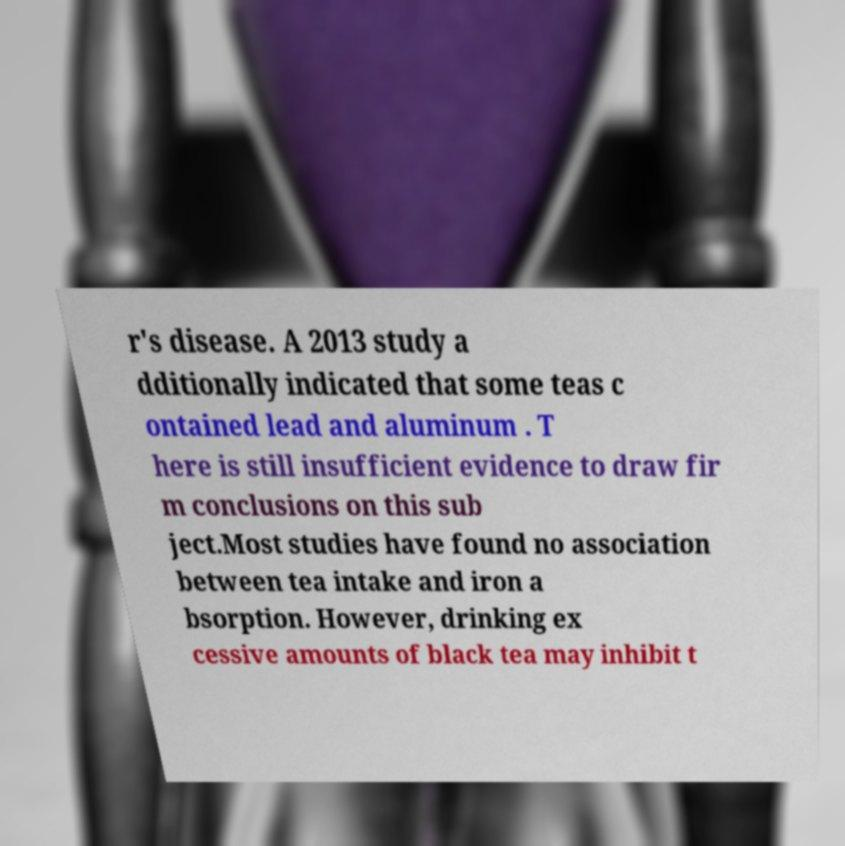Please identify and transcribe the text found in this image. r's disease. A 2013 study a dditionally indicated that some teas c ontained lead and aluminum . T here is still insufficient evidence to draw fir m conclusions on this sub ject.Most studies have found no association between tea intake and iron a bsorption. However, drinking ex cessive amounts of black tea may inhibit t 